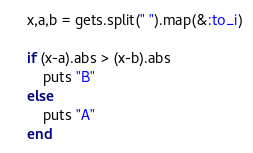Convert code to text. <code><loc_0><loc_0><loc_500><loc_500><_Ruby_>x,a,b = gets.split(" ").map(&:to_i)

if (x-a).abs > (x-b).abs
    puts "B"
else
    puts "A"
end</code> 